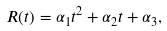Convert formula to latex. <formula><loc_0><loc_0><loc_500><loc_500>R ( t ) = \alpha _ { 1 } t ^ { 2 } + \alpha _ { 2 } t + \alpha _ { 3 } ,</formula> 